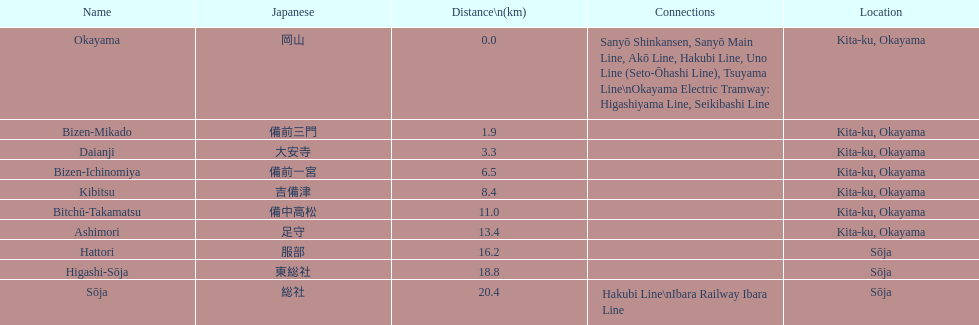Hattori and kibitsu: which of the two has a greater distance? Hattori. I'm looking to parse the entire table for insights. Could you assist me with that? {'header': ['Name', 'Japanese', 'Distance\\n(km)', 'Connections', 'Location'], 'rows': [['Okayama', '岡山', '0.0', 'Sanyō Shinkansen, Sanyō Main Line, Akō Line, Hakubi Line, Uno Line (Seto-Ōhashi Line), Tsuyama Line\\nOkayama Electric Tramway: Higashiyama Line, Seikibashi Line', 'Kita-ku, Okayama'], ['Bizen-Mikado', '備前三門', '1.9', '', 'Kita-ku, Okayama'], ['Daianji', '大安寺', '3.3', '', 'Kita-ku, Okayama'], ['Bizen-Ichinomiya', '備前一宮', '6.5', '', 'Kita-ku, Okayama'], ['Kibitsu', '吉備津', '8.4', '', 'Kita-ku, Okayama'], ['Bitchū-Takamatsu', '備中高松', '11.0', '', 'Kita-ku, Okayama'], ['Ashimori', '足守', '13.4', '', 'Kita-ku, Okayama'], ['Hattori', '服部', '16.2', '', 'Sōja'], ['Higashi-Sōja', '東総社', '18.8', '', 'Sōja'], ['Sōja', '総社', '20.4', 'Hakubi Line\\nIbara Railway Ibara Line', 'Sōja']]} 